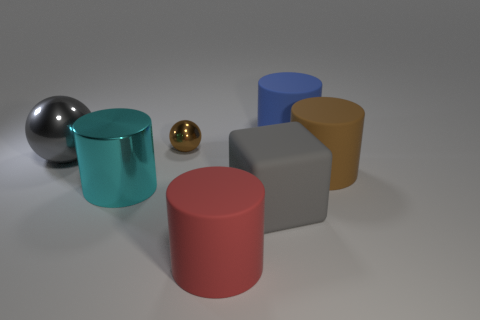Subtract all big rubber cylinders. How many cylinders are left? 1 Subtract 3 cylinders. How many cylinders are left? 1 Subtract all brown spheres. How many spheres are left? 1 Add 2 tiny brown shiny objects. How many objects exist? 9 Subtract all red spheres. Subtract all green cylinders. How many spheres are left? 2 Subtract all brown metal cubes. Subtract all blue matte cylinders. How many objects are left? 6 Add 6 small balls. How many small balls are left? 7 Add 4 tiny shiny things. How many tiny shiny things exist? 5 Subtract 0 purple blocks. How many objects are left? 7 Subtract all cubes. How many objects are left? 6 